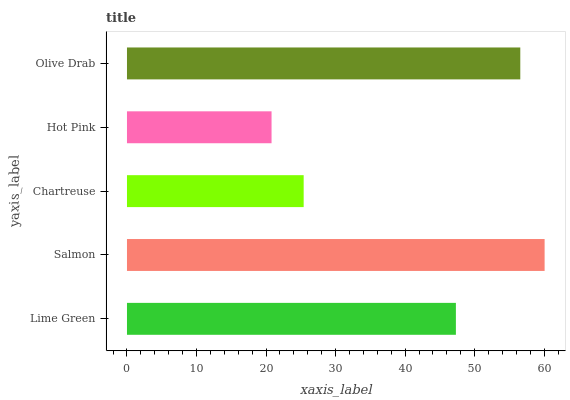Is Hot Pink the minimum?
Answer yes or no. Yes. Is Salmon the maximum?
Answer yes or no. Yes. Is Chartreuse the minimum?
Answer yes or no. No. Is Chartreuse the maximum?
Answer yes or no. No. Is Salmon greater than Chartreuse?
Answer yes or no. Yes. Is Chartreuse less than Salmon?
Answer yes or no. Yes. Is Chartreuse greater than Salmon?
Answer yes or no. No. Is Salmon less than Chartreuse?
Answer yes or no. No. Is Lime Green the high median?
Answer yes or no. Yes. Is Lime Green the low median?
Answer yes or no. Yes. Is Chartreuse the high median?
Answer yes or no. No. Is Hot Pink the low median?
Answer yes or no. No. 